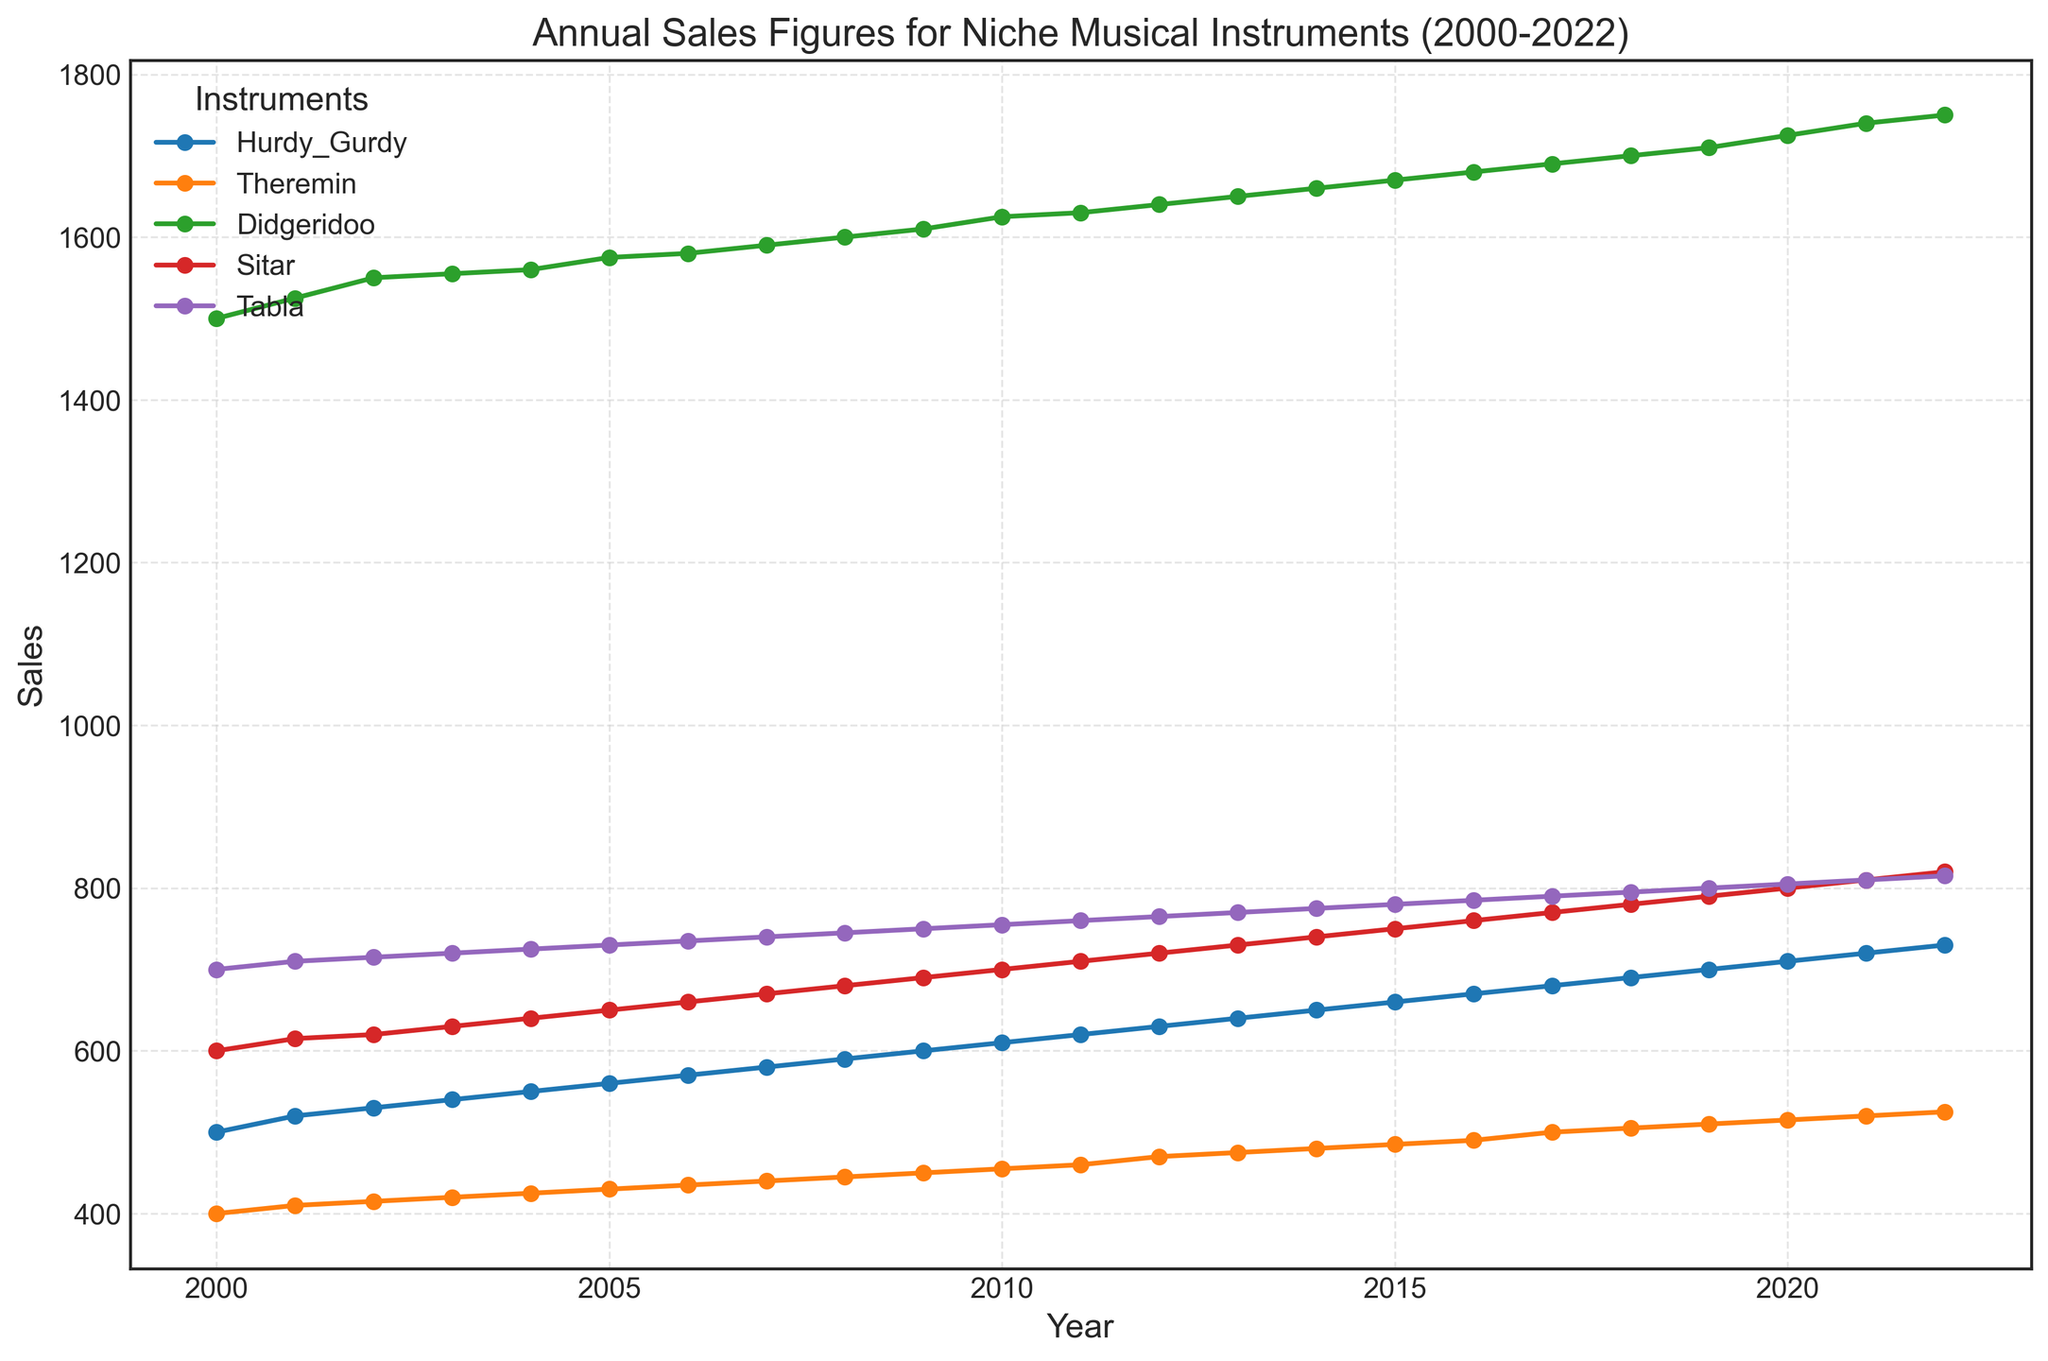What are the years when sales of the theremin were exactly 500 units or more? First, we identify the sales trend for the theremin. The data shows that sales of the theremin reached 500 units in 2017 and surpassed this value in subsequent years (2018 onwards).
Answer: 2017, 2018, 2019, 2020, 2021, 2022 Which instrument had the steepest increase in sales over the entire period? To determine this, we compare the sales increase for each instrument from 2000 to 2022. The didgeridoo had the highest sales increase from 1500 units to 1750 units, which is an increase of 250 units.
Answer: Didgeridoo Between 2015 and 2020, which instrument showed the largest percentage increase in sales? Calculate the percentage increase for each instrument between 2015 and 2020. For the theremin, the sales increased from 485 to 515, a (515 - 485) / 485 * 100 = 6.19% increase. For the didgeridoo, it increased from 1670 to 1725, a (1725 - 1670) / 1670 * 100 = 3.29% increase. Similar calculations for other instruments show that the sitar increased from 750 to 800, a (800 - 750) / 750 * 100 = 6.67% increase, the tabla from 780 to 805, a (805 - 780) / 780 * 100 = 3.21% increase, and the hurdy-gurdy from 660 to 710, a (710 - 660) / 660 * 100 = 7.58% increase. The hurdy-gurdy shows the largest percentage increase.
Answer: Hurdy-Gurdy Which year had exactly equal sales figures for the hurdy-gurdy and theremin? Inspect each year's sales figures for the hurdy-gurdy and theremin. In 2011, both have sales figures of 620 and 460 units respectively, which are not equal in any year from 2000 to 2022. Therefore, no such year exists.
Answer: No such year What is the average annual growth in sales for the sitar over the entire period? Find the annual growth by subtracting initial sales from final sales and dividing by the number of years. The sales of the sitar grew from 600 units in 2000 to 820 units in 2022. The total increase is 820 - 600 = 220 units. Over 22 years, the average annual growth is 220 / 22 = 10 units/year.
Answer: 10 units/year How do the visual markers of the sitar’s sales data compare to those of the tabla? The visual plot shows similar upward trends with circular markers connected by solid lines. Comparing visually, sitar sales markers appear slightly higher than tabla markers and maintain a consistent upward trajectory compared to the smoother, more gradual increase in tabla's sales.
Answer: Sitar markers are higher and trend consistently upwards Given the data, in which year did the hurdy-gurdy sales first exceed 600 units? Observing the sales trend, the hurdy-gurdy sales first exceeded 600 units in 2010 when the sales figure was recorded as 610 units.
Answer: 2010 